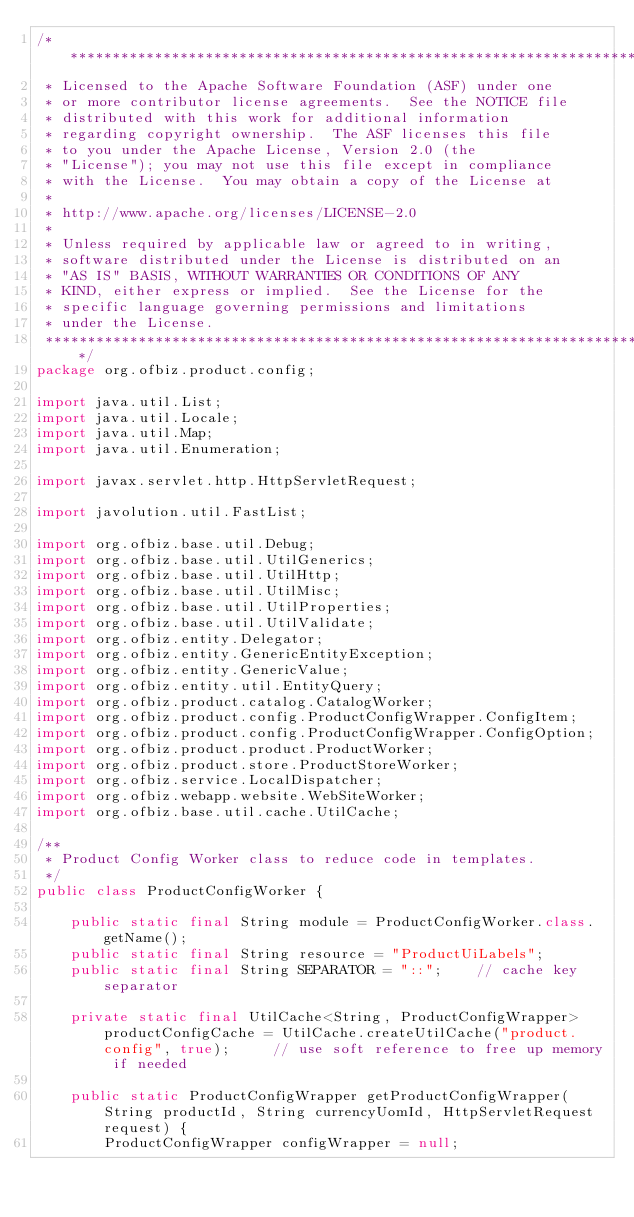Convert code to text. <code><loc_0><loc_0><loc_500><loc_500><_Java_>/*******************************************************************************
 * Licensed to the Apache Software Foundation (ASF) under one
 * or more contributor license agreements.  See the NOTICE file
 * distributed with this work for additional information
 * regarding copyright ownership.  The ASF licenses this file
 * to you under the Apache License, Version 2.0 (the
 * "License"); you may not use this file except in compliance
 * with the License.  You may obtain a copy of the License at
 *
 * http://www.apache.org/licenses/LICENSE-2.0
 *
 * Unless required by applicable law or agreed to in writing,
 * software distributed under the License is distributed on an
 * "AS IS" BASIS, WITHOUT WARRANTIES OR CONDITIONS OF ANY
 * KIND, either express or implied.  See the License for the
 * specific language governing permissions and limitations
 * under the License.
 *******************************************************************************/
package org.ofbiz.product.config;

import java.util.List;
import java.util.Locale;
import java.util.Map;
import java.util.Enumeration;

import javax.servlet.http.HttpServletRequest;

import javolution.util.FastList;

import org.ofbiz.base.util.Debug;
import org.ofbiz.base.util.UtilGenerics;
import org.ofbiz.base.util.UtilHttp;
import org.ofbiz.base.util.UtilMisc;
import org.ofbiz.base.util.UtilProperties;
import org.ofbiz.base.util.UtilValidate;
import org.ofbiz.entity.Delegator;
import org.ofbiz.entity.GenericEntityException;
import org.ofbiz.entity.GenericValue;
import org.ofbiz.entity.util.EntityQuery;
import org.ofbiz.product.catalog.CatalogWorker;
import org.ofbiz.product.config.ProductConfigWrapper.ConfigItem;
import org.ofbiz.product.config.ProductConfigWrapper.ConfigOption;
import org.ofbiz.product.product.ProductWorker;
import org.ofbiz.product.store.ProductStoreWorker;
import org.ofbiz.service.LocalDispatcher;
import org.ofbiz.webapp.website.WebSiteWorker;
import org.ofbiz.base.util.cache.UtilCache;

/**
 * Product Config Worker class to reduce code in templates.
 */
public class ProductConfigWorker {

    public static final String module = ProductConfigWorker.class.getName();
    public static final String resource = "ProductUiLabels";
    public static final String SEPARATOR = "::";    // cache key separator

    private static final UtilCache<String, ProductConfigWrapper> productConfigCache = UtilCache.createUtilCache("product.config", true);     // use soft reference to free up memory if needed

    public static ProductConfigWrapper getProductConfigWrapper(String productId, String currencyUomId, HttpServletRequest request) {
        ProductConfigWrapper configWrapper = null;</code> 